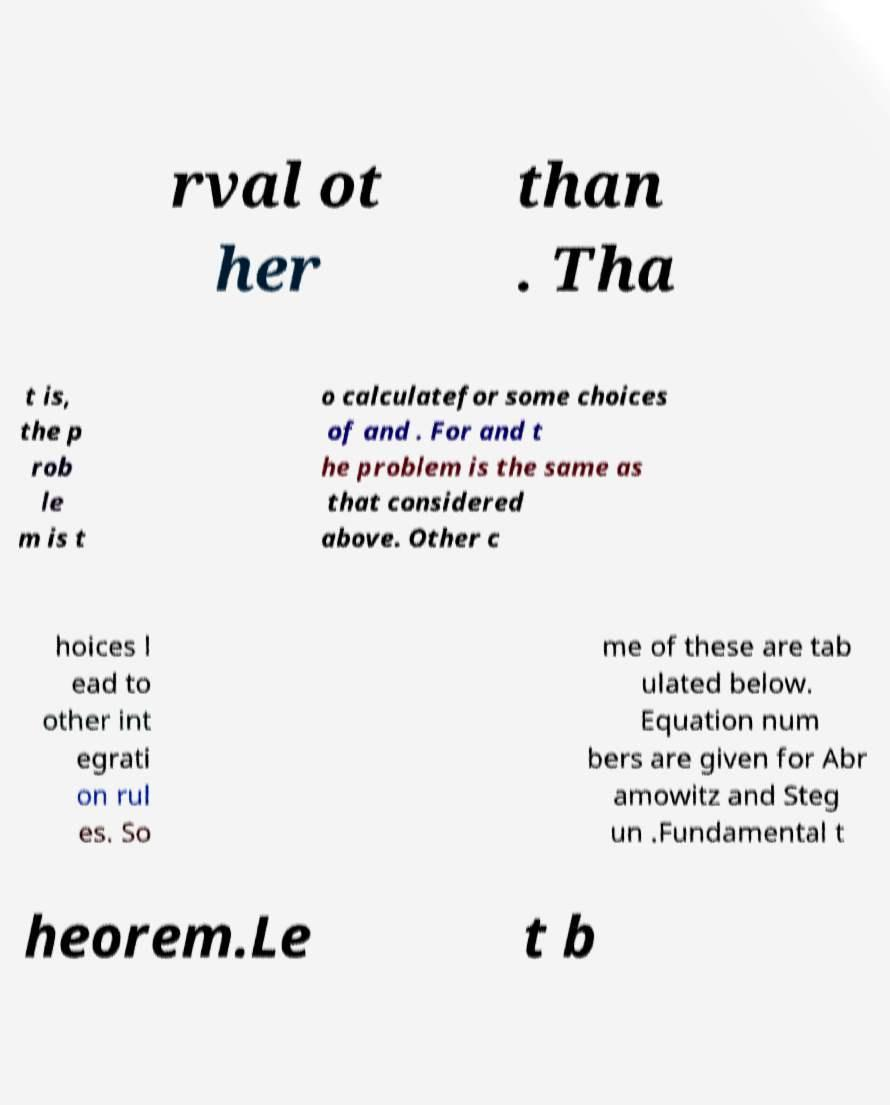Can you read and provide the text displayed in the image?This photo seems to have some interesting text. Can you extract and type it out for me? rval ot her than . Tha t is, the p rob le m is t o calculatefor some choices of and . For and t he problem is the same as that considered above. Other c hoices l ead to other int egrati on rul es. So me of these are tab ulated below. Equation num bers are given for Abr amowitz and Steg un .Fundamental t heorem.Le t b 